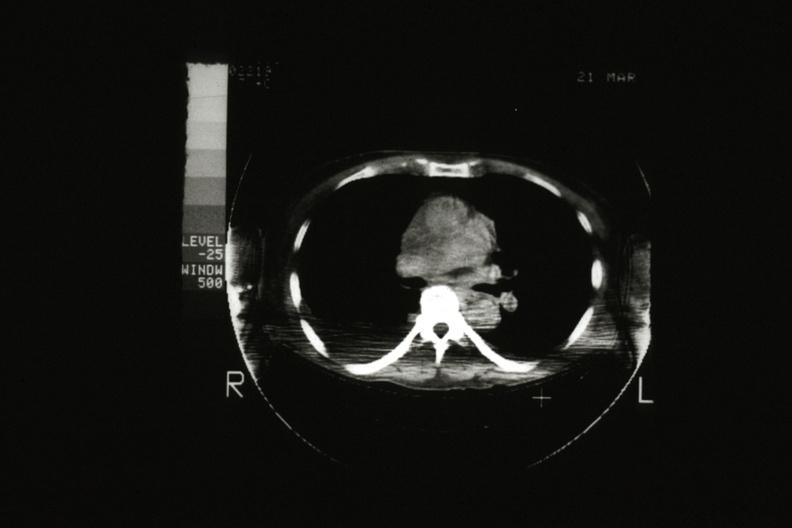does this image show cat scan showing tumor mass invading superior vena ca?
Answer the question using a single word or phrase. Yes 